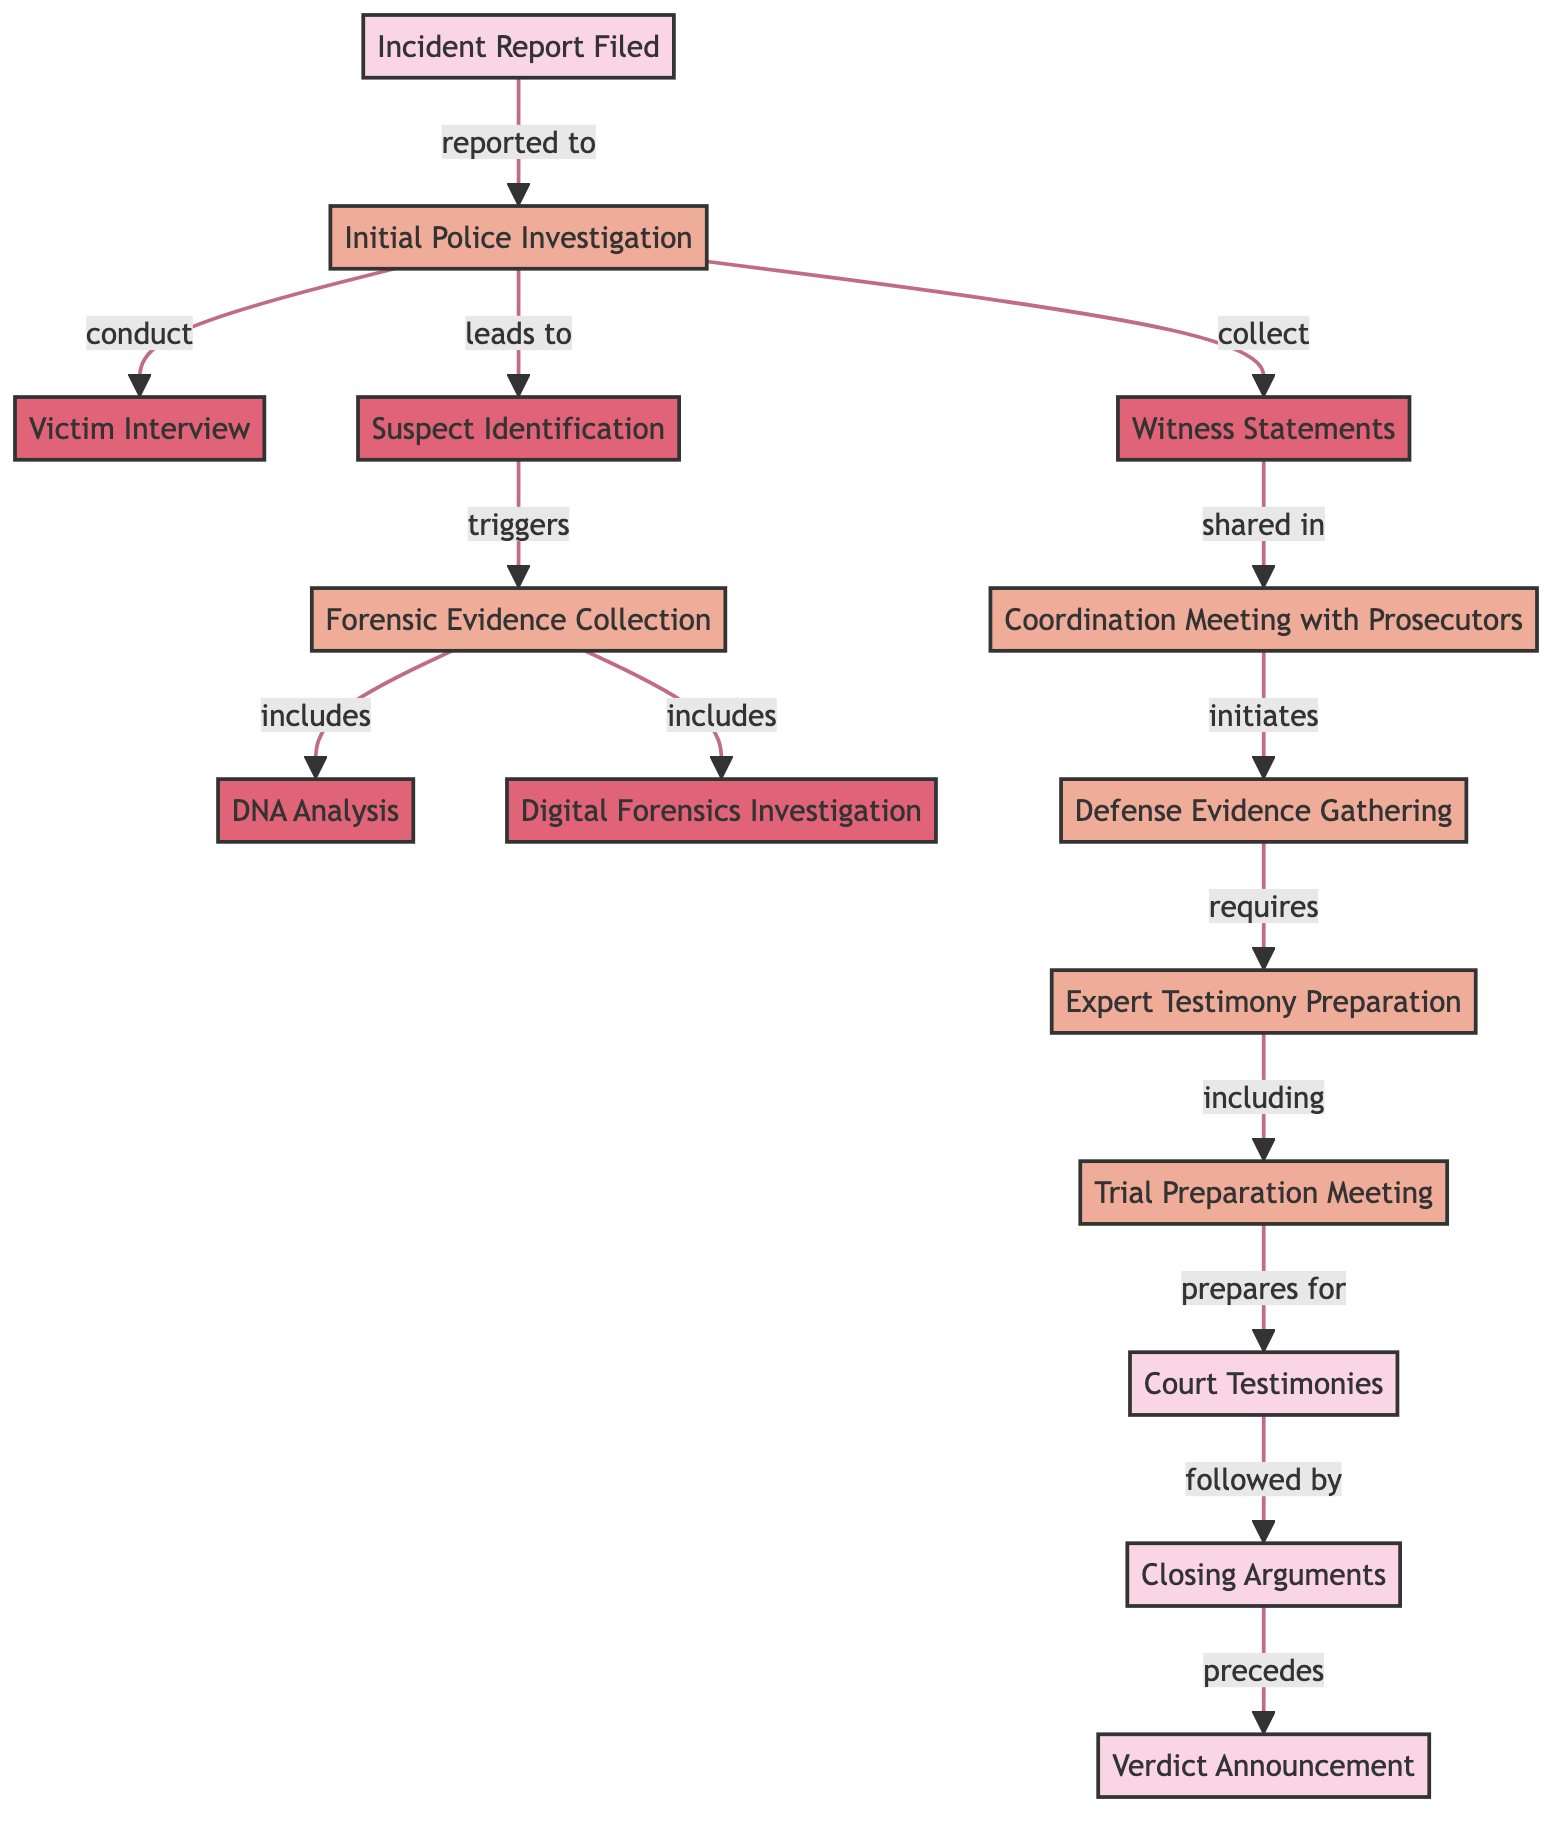What is the first event in the timeline? The diagram shows "Incident Report Filed" as the first node, indicating the starting point of the timeline.
Answer: Incident Report Filed How many processes are depicted in the diagram? By counting the nodes and identifying those labeled as "process," we find there are six processes total.
Answer: 6 What is the label of the node directly preceding "Court Testimonies"? "Trial Preparation Meeting" is directly preceding "Court Testimonies," as indicated by the directed edge leading into it from the left.
Answer: Trial Preparation Meeting What action leads from "Suspect Identification" to "Forensic Evidence Collection"? The label on the edge connecting these two nodes indicates that "Suspect Identification" triggers "Forensic Evidence Collection."
Answer: triggers Which task is required after "Defense Evidence Gathering"? The diagram shows that "Expert Testimony Preparation" is the task that directly follows "Defense Evidence Gathering."
Answer: Expert Testimony Preparation What event follows "Closing Arguments" in this timeline? The diagram indicates that "Verdict Announcement" comes directly after "Closing Arguments," delineating the sequence of events in the courtroom.
Answer: Verdict Announcement What type of relationships can be observed between "Witness Statements" and "Coordination Meeting with Prosecutors"? The edge connecting these two nodes is labeled "shared in," indicating that witness statements are indeed shared in the coordination meeting.
Answer: shared in What node does "Digital Forensics Investigation" come after in the evidence collection process? Following the flow of actions, "Digital Forensics Investigation" comes after "Forensic Evidence Collection," as indicated by the arrows and their connections.
Answer: Forensic Evidence Collection 